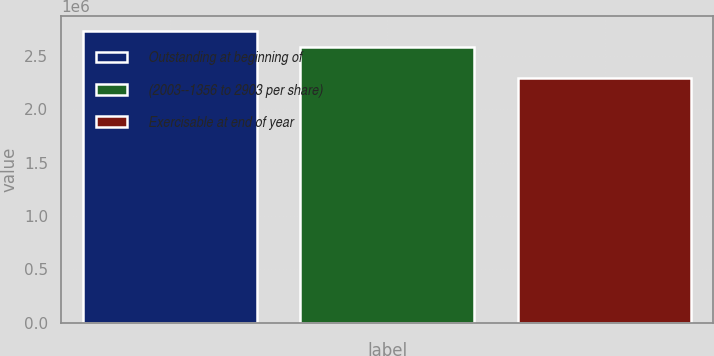Convert chart to OTSL. <chart><loc_0><loc_0><loc_500><loc_500><bar_chart><fcel>Outstanding at beginning of<fcel>(2003--1356 to 2903 per share)<fcel>Exercisable at end of year<nl><fcel>2.7336e+06<fcel>2.585e+06<fcel>2.2886e+06<nl></chart> 